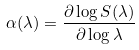<formula> <loc_0><loc_0><loc_500><loc_500>\alpha ( \lambda ) = \frac { \partial \log S ( \lambda ) } { \partial \log \lambda }</formula> 